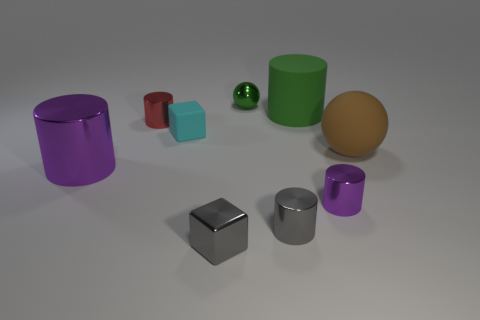Is there any object in the image that seems out of place compared to the others? All the objects appear to belong to the same set of geometric shapes commonly used for visualization. However, if we were to consider the overall coherence, the brown egg-shaped object might seem slightly out of place as it has an organic shape that differs from the perfect geometrical shapes of the other objects. 